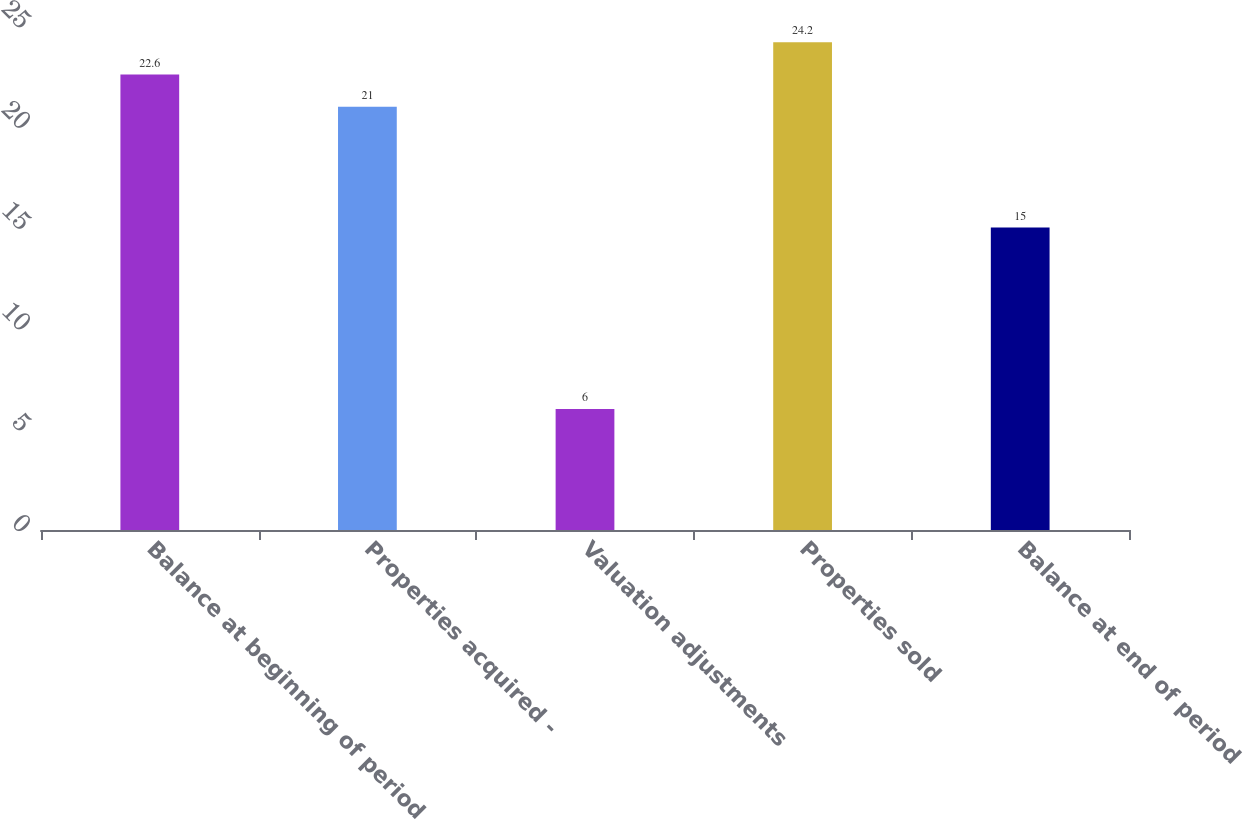<chart> <loc_0><loc_0><loc_500><loc_500><bar_chart><fcel>Balance at beginning of period<fcel>Properties acquired -<fcel>Valuation adjustments<fcel>Properties sold<fcel>Balance at end of period<nl><fcel>22.6<fcel>21<fcel>6<fcel>24.2<fcel>15<nl></chart> 